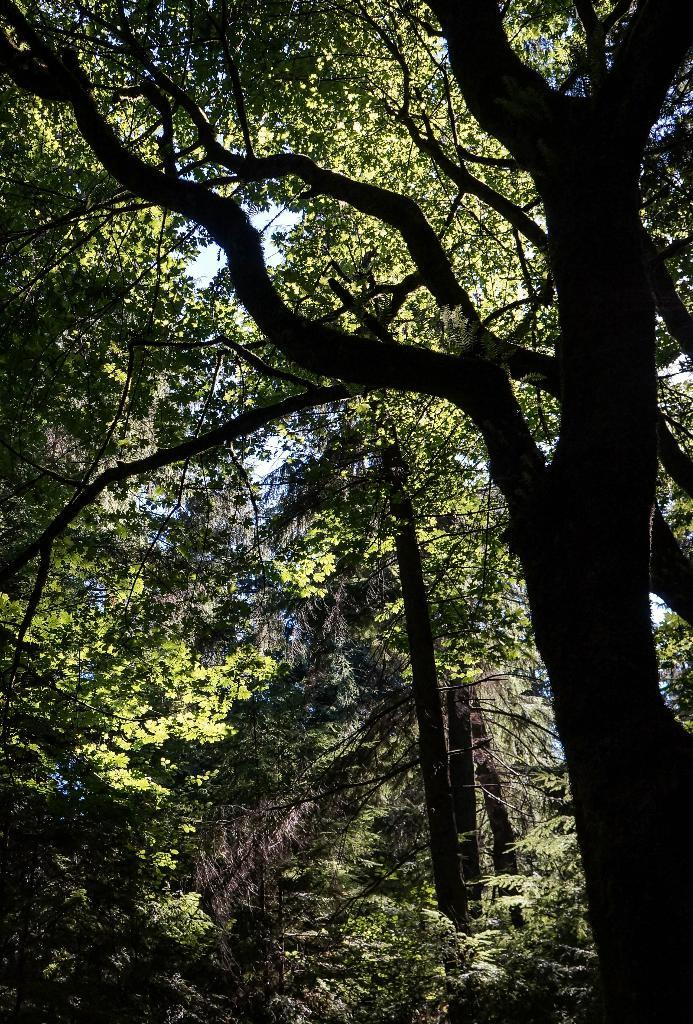What type of natural elements can be seen in the image? There are trees in the image. What colors are present in the sky in the image? The sky is a combination of white and blue colors. What title does the person in the image hold? There is no person present in the image, so it is not possible to determine their title. 